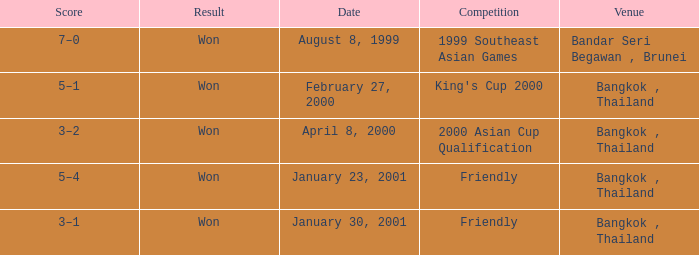What was the result of the game that was played on february 27, 2000? Won. 